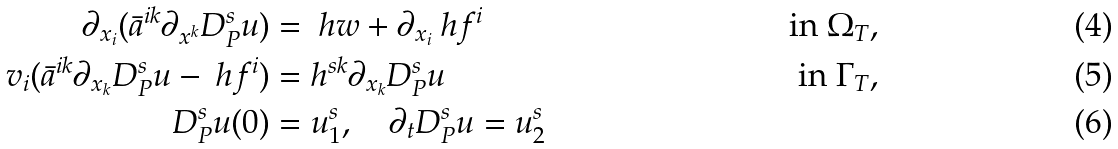Convert formula to latex. <formula><loc_0><loc_0><loc_500><loc_500>\partial _ { x _ { i } } ( \bar { a } ^ { i k } \partial _ { x ^ { k } } D ^ { s } _ { P } u ) & = \ h w + \partial _ { x _ { i } } \ h f ^ { i } & \text { in } \Omega _ { T } , \\ v _ { i } ( \bar { a } ^ { i k } \partial _ { x _ { k } } D ^ { s } _ { P } u - \ h f ^ { i } ) & = h ^ { s k } \partial _ { x _ { k } } D ^ { s } _ { P } u & \text { in } \Gamma _ { T } , \\ D ^ { s } _ { P } u ( 0 ) & = u _ { 1 } ^ { s } , \quad \partial _ { t } D ^ { s } _ { P } u = u _ { 2 } ^ { s }</formula> 